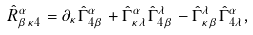<formula> <loc_0><loc_0><loc_500><loc_500>\hat { R } ^ { \alpha } _ { \beta \kappa 4 } = \partial _ { \kappa } \hat { \Gamma } ^ { \alpha } _ { 4 \beta } + \hat { \Gamma } ^ { \alpha } _ { \kappa \lambda } \hat { \Gamma } ^ { \lambda } _ { 4 \beta } - \hat { \Gamma } ^ { \lambda } _ { \kappa \beta } \hat { \Gamma } ^ { \alpha } _ { 4 \lambda } ,</formula> 